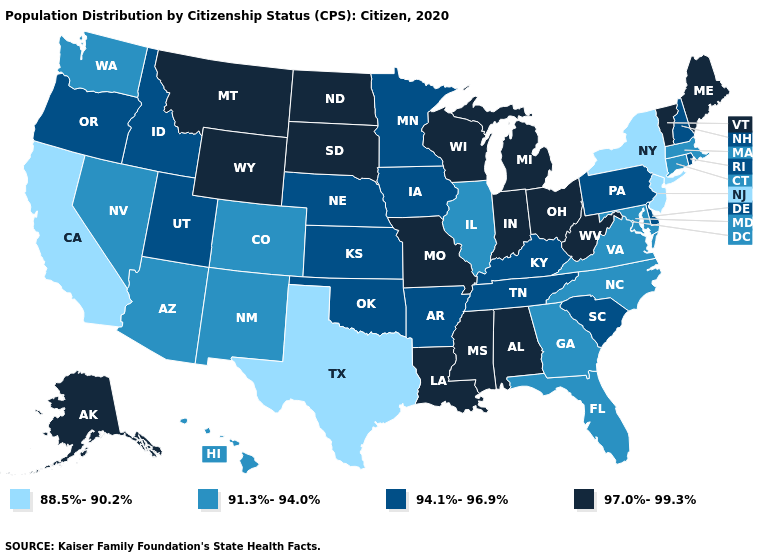What is the value of Missouri?
Keep it brief. 97.0%-99.3%. Does the first symbol in the legend represent the smallest category?
Answer briefly. Yes. What is the lowest value in the Northeast?
Keep it brief. 88.5%-90.2%. Among the states that border California , which have the lowest value?
Write a very short answer. Arizona, Nevada. What is the highest value in the USA?
Answer briefly. 97.0%-99.3%. Among the states that border New Mexico , which have the lowest value?
Write a very short answer. Texas. Name the states that have a value in the range 91.3%-94.0%?
Give a very brief answer. Arizona, Colorado, Connecticut, Florida, Georgia, Hawaii, Illinois, Maryland, Massachusetts, Nevada, New Mexico, North Carolina, Virginia, Washington. What is the value of Utah?
Quick response, please. 94.1%-96.9%. Which states hav the highest value in the South?
Concise answer only. Alabama, Louisiana, Mississippi, West Virginia. Does Pennsylvania have the same value as Wyoming?
Short answer required. No. Does New Jersey have the lowest value in the Northeast?
Short answer required. Yes. What is the highest value in the USA?
Concise answer only. 97.0%-99.3%. What is the value of Alaska?
Short answer required. 97.0%-99.3%. Name the states that have a value in the range 94.1%-96.9%?
Give a very brief answer. Arkansas, Delaware, Idaho, Iowa, Kansas, Kentucky, Minnesota, Nebraska, New Hampshire, Oklahoma, Oregon, Pennsylvania, Rhode Island, South Carolina, Tennessee, Utah. Which states hav the highest value in the South?
Answer briefly. Alabama, Louisiana, Mississippi, West Virginia. 